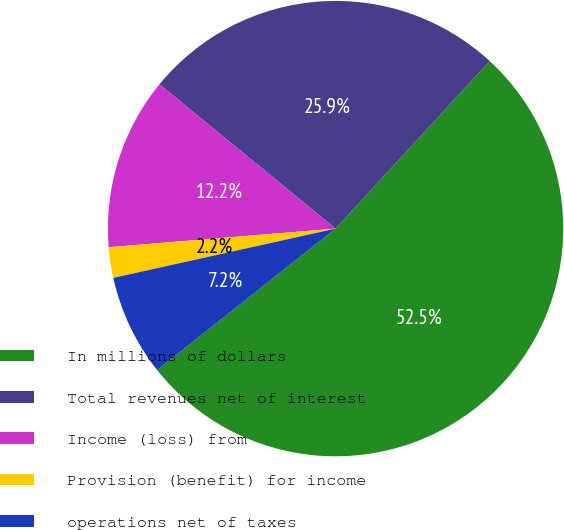Convert chart. <chart><loc_0><loc_0><loc_500><loc_500><pie_chart><fcel>In millions of dollars<fcel>Total revenues net of interest<fcel>Income (loss) from<fcel>Provision (benefit) for income<fcel>operations net of taxes<nl><fcel>52.48%<fcel>25.91%<fcel>12.23%<fcel>2.17%<fcel>7.2%<nl></chart> 